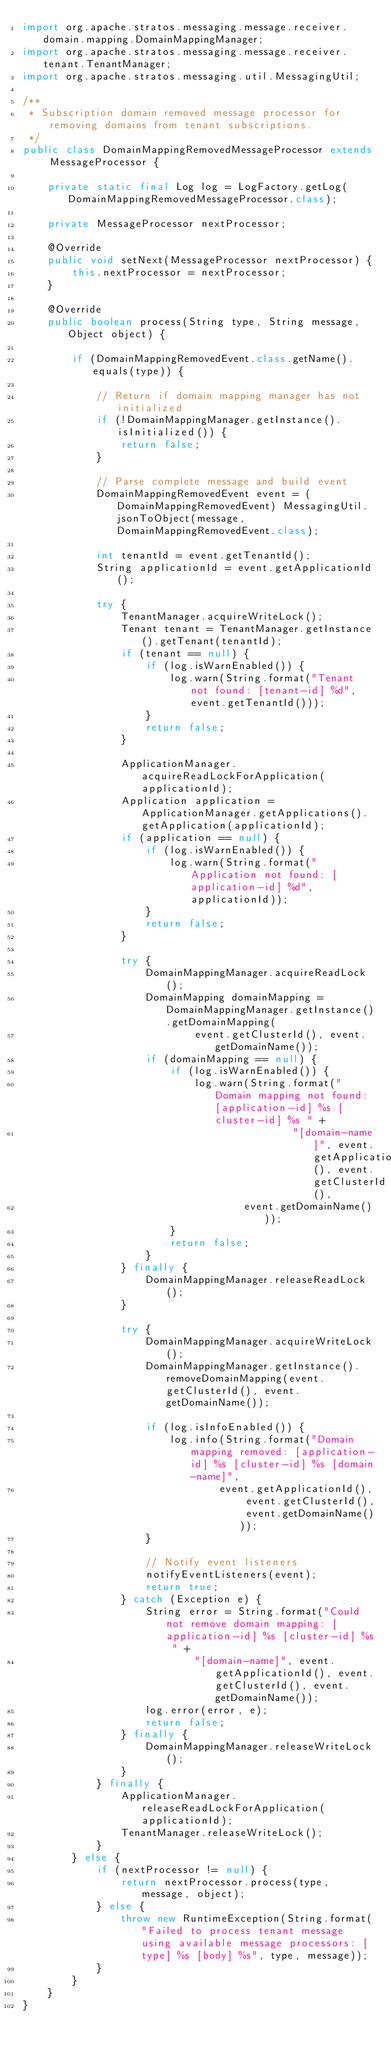Convert code to text. <code><loc_0><loc_0><loc_500><loc_500><_Java_>import org.apache.stratos.messaging.message.receiver.domain.mapping.DomainMappingManager;
import org.apache.stratos.messaging.message.receiver.tenant.TenantManager;
import org.apache.stratos.messaging.util.MessagingUtil;

/**
 * Subscription domain removed message processor for removing domains from tenant subscriptions.
 */
public class DomainMappingRemovedMessageProcessor extends MessageProcessor {

    private static final Log log = LogFactory.getLog(DomainMappingRemovedMessageProcessor.class);

    private MessageProcessor nextProcessor;

    @Override
    public void setNext(MessageProcessor nextProcessor) {
        this.nextProcessor = nextProcessor;
    }

    @Override
    public boolean process(String type, String message, Object object) {

        if (DomainMappingRemovedEvent.class.getName().equals(type)) {

            // Return if domain mapping manager has not initialized
            if (!DomainMappingManager.getInstance().isInitialized()) {
                return false;
            }

            // Parse complete message and build event
            DomainMappingRemovedEvent event = (DomainMappingRemovedEvent) MessagingUtil.jsonToObject(message, DomainMappingRemovedEvent.class);

            int tenantId = event.getTenantId();
            String applicationId = event.getApplicationId();

            try {
                TenantManager.acquireWriteLock();
                Tenant tenant = TenantManager.getInstance().getTenant(tenantId);
                if (tenant == null) {
                    if (log.isWarnEnabled()) {
                        log.warn(String.format("Tenant not found: [tenant-id] %d", event.getTenantId()));
                    }
                    return false;
                }

                ApplicationManager.acquireReadLockForApplication(applicationId);
                Application application = ApplicationManager.getApplications().getApplication(applicationId);
                if (application == null) {
                    if (log.isWarnEnabled()) {
                        log.warn(String.format("Application not found: [application-id] %d", applicationId));
                    }
                    return false;
                }

                try {
                    DomainMappingManager.acquireReadLock();
                    DomainMapping domainMapping = DomainMappingManager.getInstance().getDomainMapping(
                            event.getClusterId(), event.getDomainName());
                    if (domainMapping == null) {
                        if (log.isWarnEnabled()) {
                            log.warn(String.format("Domain mapping not found: [application-id] %s [cluster-id] %s " +
                                            "[domain-name]", event.getApplicationId(), event.getClusterId(),
                                    event.getDomainName()));
                        }
                        return false;
                    }
                } finally {
                    DomainMappingManager.releaseReadLock();
                }

                try {
                    DomainMappingManager.acquireWriteLock();
                    DomainMappingManager.getInstance().removeDomainMapping(event.getClusterId(), event.getDomainName());

                    if (log.isInfoEnabled()) {
                        log.info(String.format("Domain mapping removed: [application-id] %s [cluster-id] %s [domain-name]",
                                event.getApplicationId(), event.getClusterId(), event.getDomainName()));
                    }

                    // Notify event listeners
                    notifyEventListeners(event);
                    return true;
                } catch (Exception e) {
                    String error = String.format("Could not remove domain mapping: [application-id] %s [cluster-id] %s " +
                            "[domain-name]", event.getApplicationId(), event.getClusterId(), event.getDomainName());
                    log.error(error, e);
                    return false;
                } finally {
                    DomainMappingManager.releaseWriteLock();
                }
            } finally {
                ApplicationManager.releaseReadLockForApplication(applicationId);
                TenantManager.releaseWriteLock();
            }
        } else {
            if (nextProcessor != null) {
                return nextProcessor.process(type, message, object);
            } else {
                throw new RuntimeException(String.format("Failed to process tenant message using available message processors: [type] %s [body] %s", type, message));
            }
        }
    }
}
</code> 